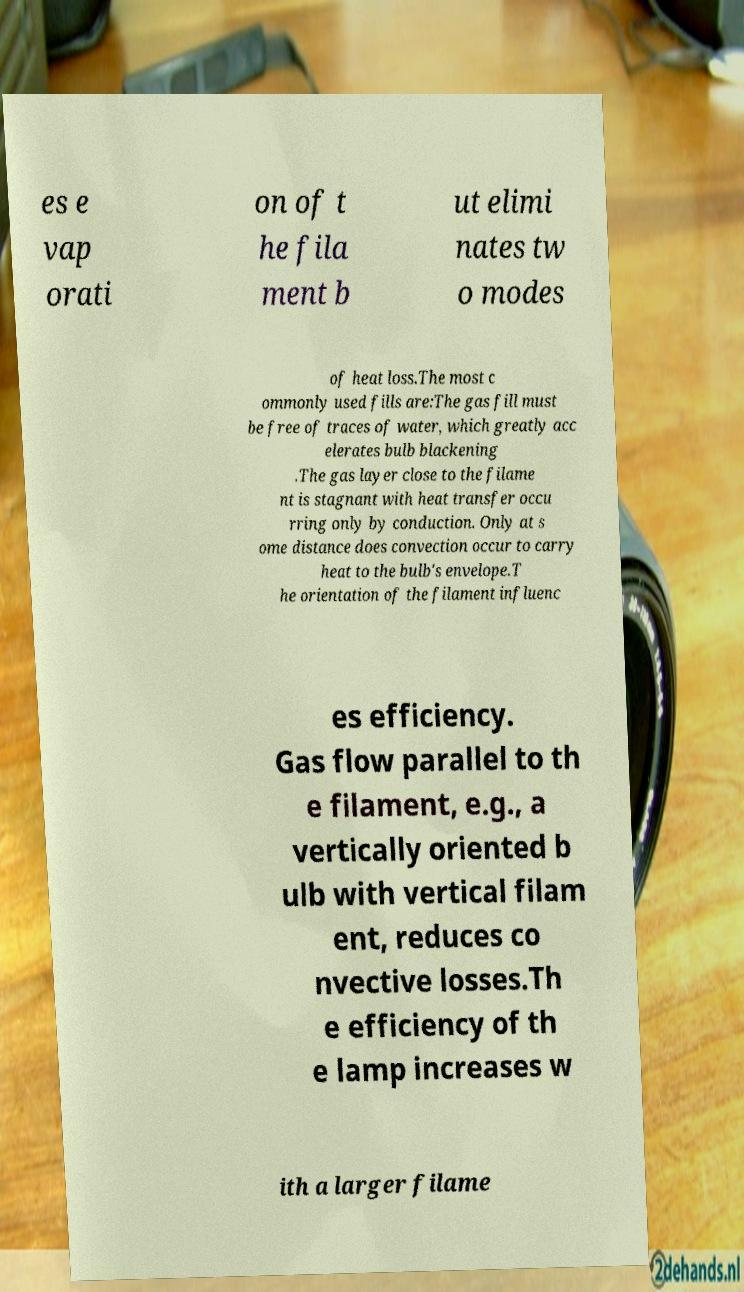Please identify and transcribe the text found in this image. es e vap orati on of t he fila ment b ut elimi nates tw o modes of heat loss.The most c ommonly used fills are:The gas fill must be free of traces of water, which greatly acc elerates bulb blackening .The gas layer close to the filame nt is stagnant with heat transfer occu rring only by conduction. Only at s ome distance does convection occur to carry heat to the bulb's envelope.T he orientation of the filament influenc es efficiency. Gas flow parallel to th e filament, e.g., a vertically oriented b ulb with vertical filam ent, reduces co nvective losses.Th e efficiency of th e lamp increases w ith a larger filame 